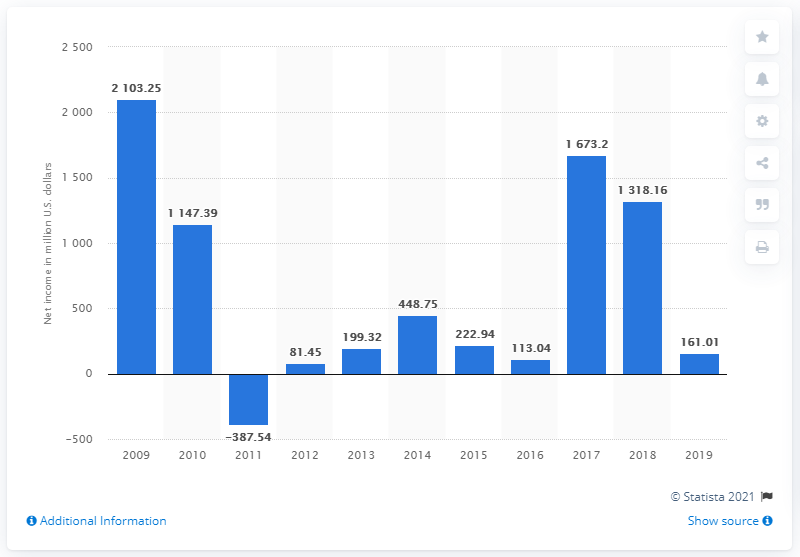Draw attention to some important aspects in this diagram. LG Electronics' net income in 2019 was 161.01. 